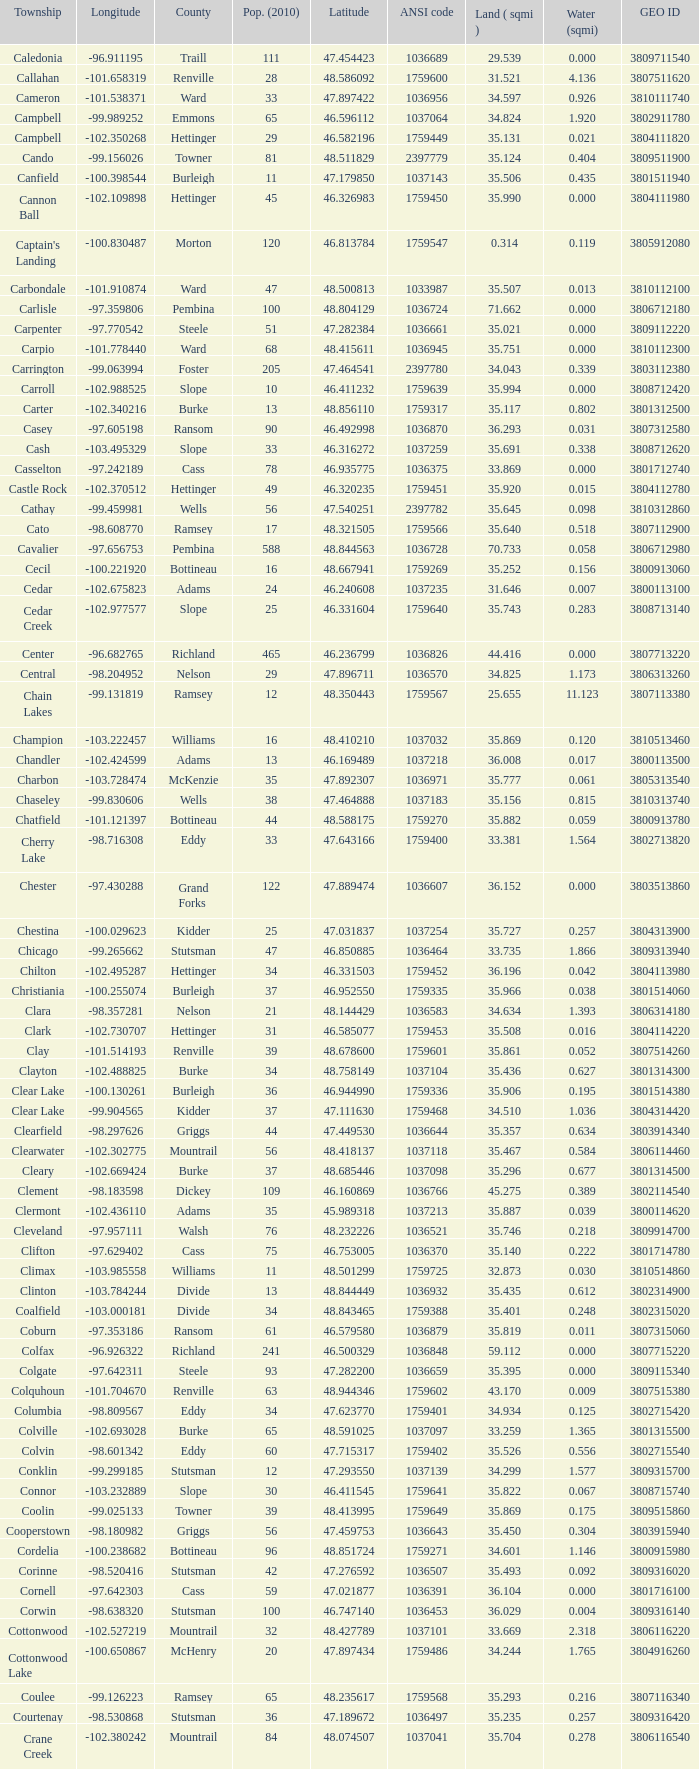What was the longitude of the township with a latitude of 48.075823? -98.857272. 